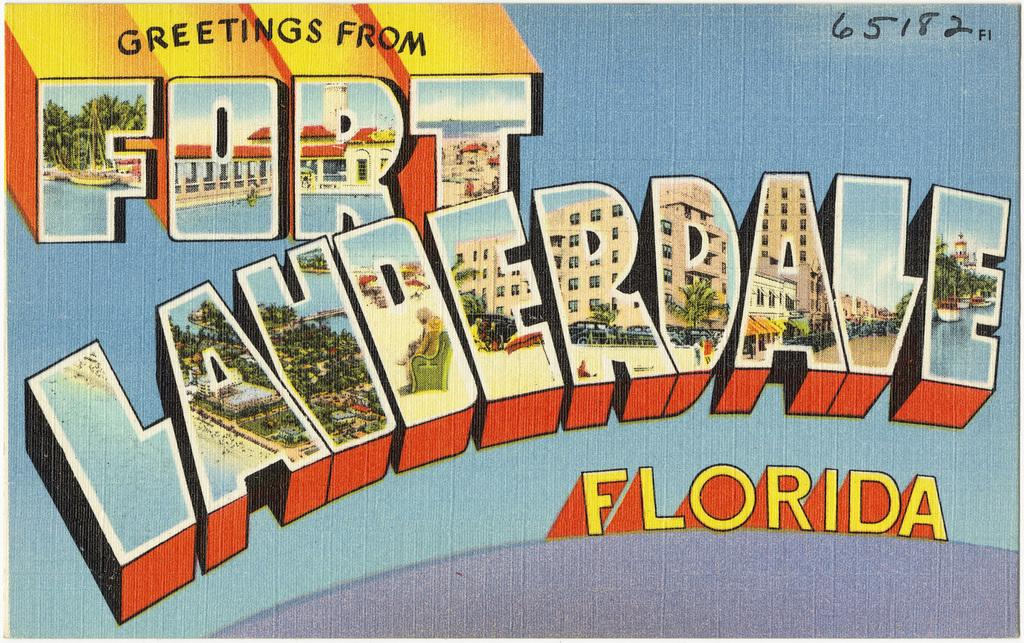What is present on the poster in the picture? There is a poster in the picture, which contains words, numbers, and images. Can you describe the content of the poster in more detail? The poster contains words, numbers, and images, but the specific content cannot be determined from the provided facts. What type of information might be conveyed by the poster? The poster might convey information related to the words, numbers, and images present on it. How many icicles can be seen hanging from the poster in the image? There are no icicles present in the image, as it features a poster with words, numbers, and images. 